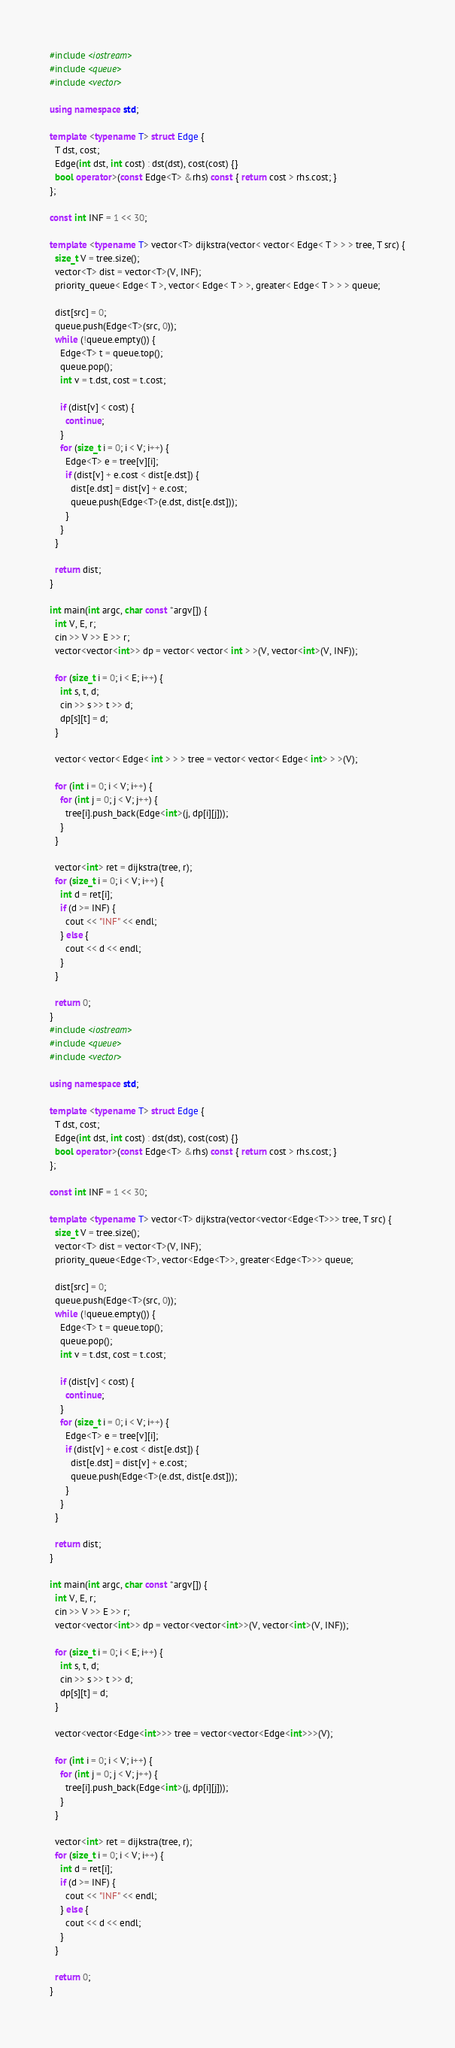<code> <loc_0><loc_0><loc_500><loc_500><_C++_>#include <iostream>
#include <queue>
#include <vector>

using namespace std;

template <typename T> struct Edge {
  T dst, cost;
  Edge(int dst, int cost) : dst(dst), cost(cost) {}
  bool operator>(const Edge<T> &rhs) const { return cost > rhs.cost; }
};

const int INF = 1 << 30;

template <typename T> vector<T> dijkstra(vector< vector< Edge< T > > > tree, T src) {
  size_t V = tree.size();
  vector<T> dist = vector<T>(V, INF);
  priority_queue< Edge< T >, vector< Edge< T > >, greater< Edge< T > > > queue;

  dist[src] = 0;
  queue.push(Edge<T>(src, 0));
  while (!queue.empty()) {
    Edge<T> t = queue.top();
    queue.pop();
    int v = t.dst, cost = t.cost;

    if (dist[v] < cost) {
      continue;
    }
    for (size_t i = 0; i < V; i++) {
      Edge<T> e = tree[v][i];
      if (dist[v] + e.cost < dist[e.dst]) {
        dist[e.dst] = dist[v] + e.cost;
        queue.push(Edge<T>(e.dst, dist[e.dst]));
      }
    }
  }

  return dist;
}

int main(int argc, char const *argv[]) {
  int V, E, r;
  cin >> V >> E >> r;
  vector<vector<int>> dp = vector< vector< int > >(V, vector<int>(V, INF));

  for (size_t i = 0; i < E; i++) {
    int s, t, d;
    cin >> s >> t >> d;
    dp[s][t] = d;
  }

  vector< vector< Edge< int > > > tree = vector< vector< Edge< int> > >(V);

  for (int i = 0; i < V; i++) {
    for (int j = 0; j < V; j++) {
      tree[i].push_back(Edge<int>(j, dp[i][j]));
    }
  }

  vector<int> ret = dijkstra(tree, r);
  for (size_t i = 0; i < V; i++) {
    int d = ret[i];
    if (d >= INF) {
      cout << "INF" << endl;
    } else {
      cout << d << endl;
    }
  }

  return 0;
}
#include <iostream>
#include <queue>
#include <vector>

using namespace std;

template <typename T> struct Edge {
  T dst, cost;
  Edge(int dst, int cost) : dst(dst), cost(cost) {}
  bool operator>(const Edge<T> &rhs) const { return cost > rhs.cost; }
};

const int INF = 1 << 30;

template <typename T> vector<T> dijkstra(vector<vector<Edge<T>>> tree, T src) {
  size_t V = tree.size();
  vector<T> dist = vector<T>(V, INF);
  priority_queue<Edge<T>, vector<Edge<T>>, greater<Edge<T>>> queue;

  dist[src] = 0;
  queue.push(Edge<T>(src, 0));
  while (!queue.empty()) {
    Edge<T> t = queue.top();
    queue.pop();
    int v = t.dst, cost = t.cost;

    if (dist[v] < cost) {
      continue;
    }
    for (size_t i = 0; i < V; i++) {
      Edge<T> e = tree[v][i];
      if (dist[v] + e.cost < dist[e.dst]) {
        dist[e.dst] = dist[v] + e.cost;
        queue.push(Edge<T>(e.dst, dist[e.dst]));
      }
    }
  }

  return dist;
}

int main(int argc, char const *argv[]) {
  int V, E, r;
  cin >> V >> E >> r;
  vector<vector<int>> dp = vector<vector<int>>(V, vector<int>(V, INF));

  for (size_t i = 0; i < E; i++) {
    int s, t, d;
    cin >> s >> t >> d;
    dp[s][t] = d;
  }

  vector<vector<Edge<int>>> tree = vector<vector<Edge<int>>>(V);

  for (int i = 0; i < V; i++) {
    for (int j = 0; j < V; j++) {
      tree[i].push_back(Edge<int>(j, dp[i][j]));
    }
  }

  vector<int> ret = dijkstra(tree, r);
  for (size_t i = 0; i < V; i++) {
    int d = ret[i];
    if (d >= INF) {
      cout << "INF" << endl;
    } else {
      cout << d << endl;
    }
  }

  return 0;
}

</code> 